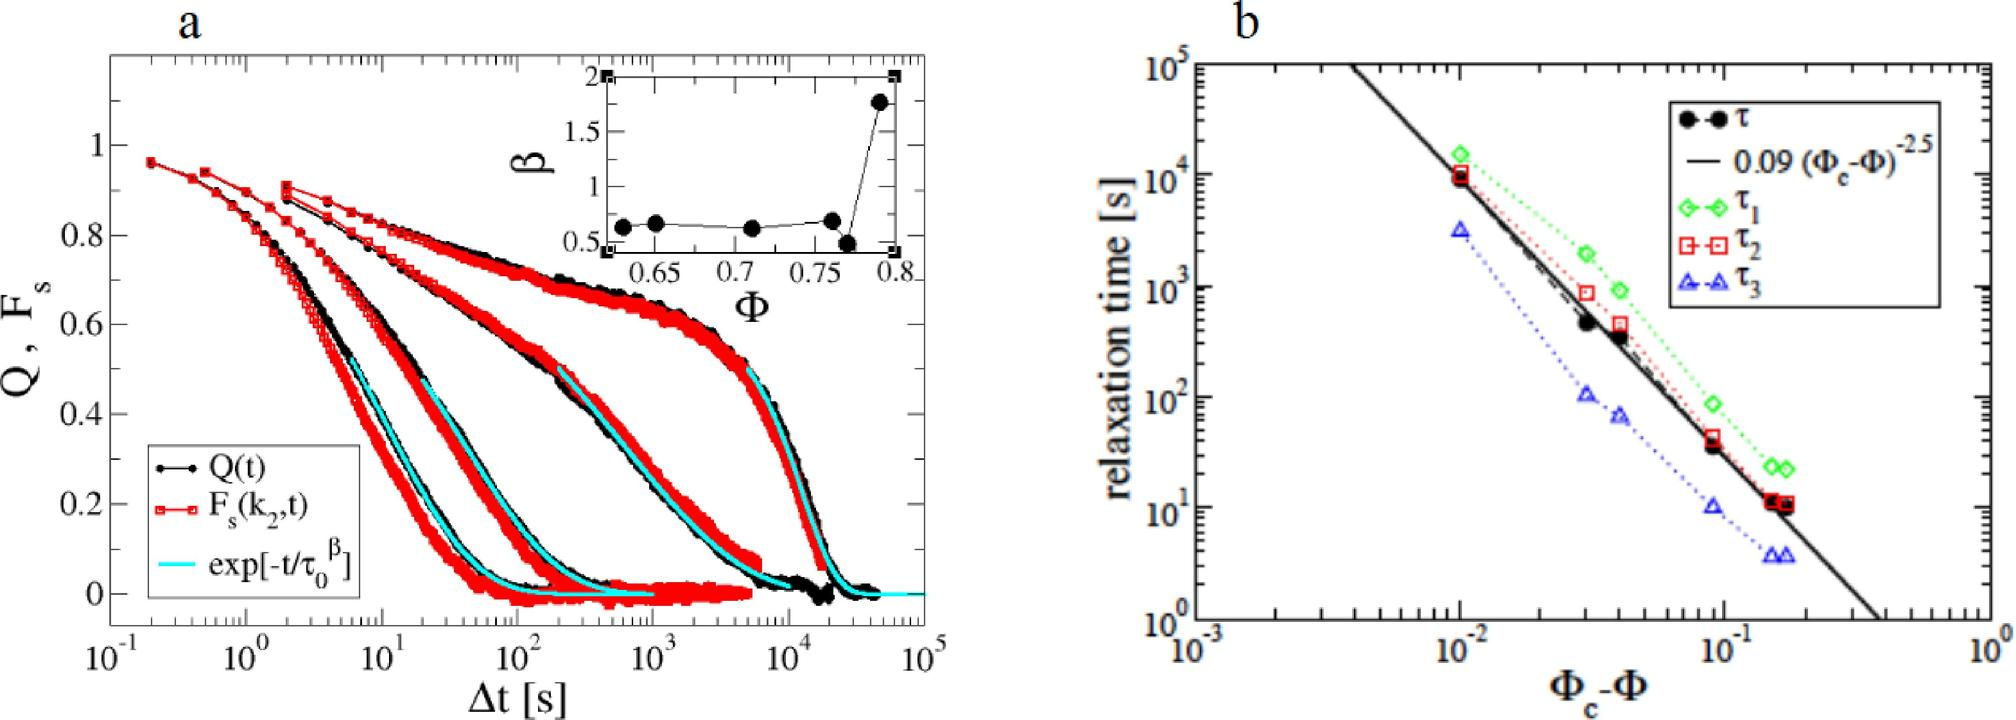Can you explain how the different colors in figure b correlate with the different types of relaxation times? Certainly! In figure b, the different colors represent different types of relaxation times: 
 (black circles), 
 (green squares), 
 (red diamonds), and 
 (blue triangles). Each color corresponds to empirical data collected under varying conditions, plotted against the ratio (
 - 
_c) on a logarithmic scale. The different markers and colors help in distinguishing the distinct experimental setups or theoretical conditions applied to observe how relaxation times vary under these different circumstances. 